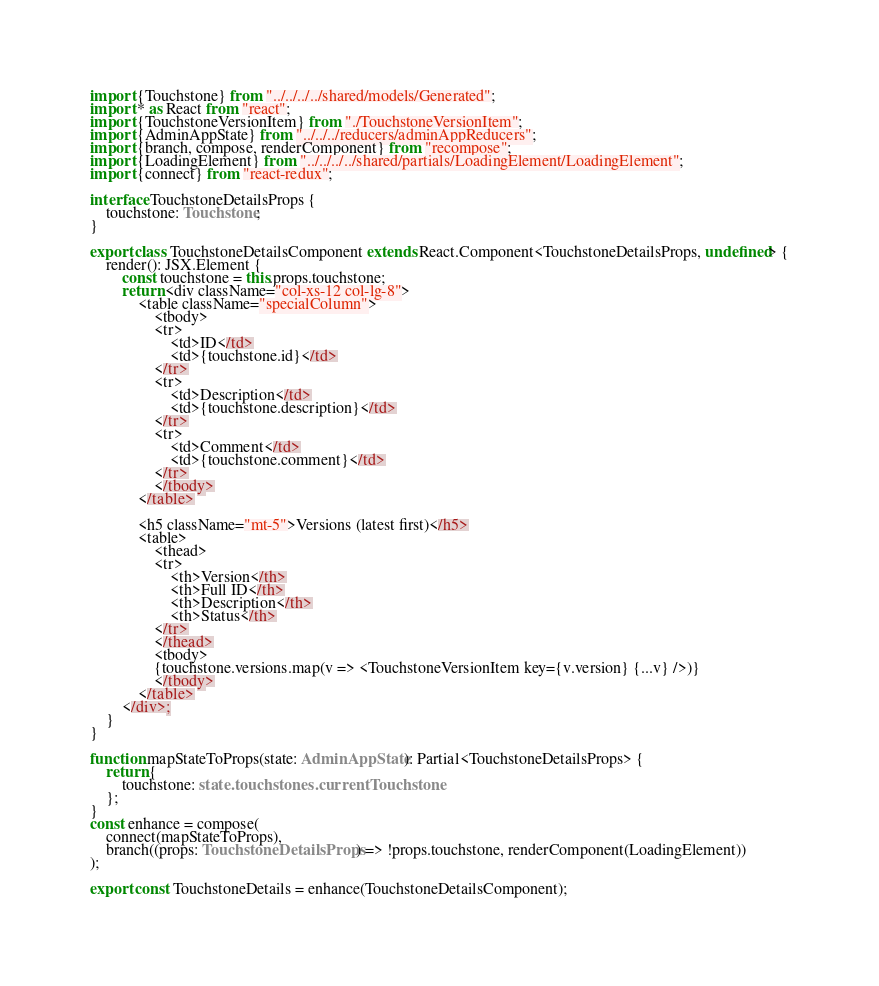<code> <loc_0><loc_0><loc_500><loc_500><_TypeScript_>import {Touchstone} from "../../../../shared/models/Generated";
import * as React from "react";
import {TouchstoneVersionItem} from "./TouchstoneVersionItem";
import {AdminAppState} from "../../../reducers/adminAppReducers";
import {branch, compose, renderComponent} from "recompose";
import {LoadingElement} from "../../../../shared/partials/LoadingElement/LoadingElement";
import {connect} from "react-redux";

interface TouchstoneDetailsProps {
    touchstone: Touchstone;
}

export class TouchstoneDetailsComponent extends React.Component<TouchstoneDetailsProps, undefined> {
    render(): JSX.Element {
        const touchstone = this.props.touchstone;
        return <div className="col-xs-12 col-lg-8">
            <table className="specialColumn">
                <tbody>
                <tr>
                    <td>ID</td>
                    <td>{touchstone.id}</td>
                </tr>
                <tr>
                    <td>Description</td>
                    <td>{touchstone.description}</td>
                </tr>
                <tr>
                    <td>Comment</td>
                    <td>{touchstone.comment}</td>
                </tr>
                </tbody>
            </table>

            <h5 className="mt-5">Versions (latest first)</h5>
            <table>
                <thead>
                <tr>
                    <th>Version</th>
                    <th>Full ID</th>
                    <th>Description</th>
                    <th>Status</th>
                </tr>
                </thead>
                <tbody>
                {touchstone.versions.map(v => <TouchstoneVersionItem key={v.version} {...v} />)}
                </tbody>
            </table>
        </div>;
    }
}

function mapStateToProps(state: AdminAppState): Partial<TouchstoneDetailsProps> {
    return {
        touchstone: state.touchstones.currentTouchstone
    };
}
const enhance = compose(
    connect(mapStateToProps),
    branch((props: TouchstoneDetailsProps) => !props.touchstone, renderComponent(LoadingElement))
);

export const TouchstoneDetails = enhance(TouchstoneDetailsComponent);</code> 